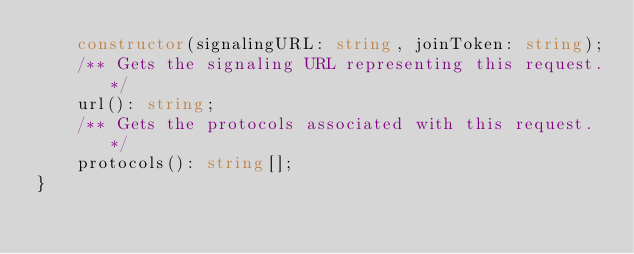Convert code to text. <code><loc_0><loc_0><loc_500><loc_500><_TypeScript_>    constructor(signalingURL: string, joinToken: string);
    /** Gets the signaling URL representing this request.*/
    url(): string;
    /** Gets the protocols associated with this request.*/
    protocols(): string[];
}
</code> 